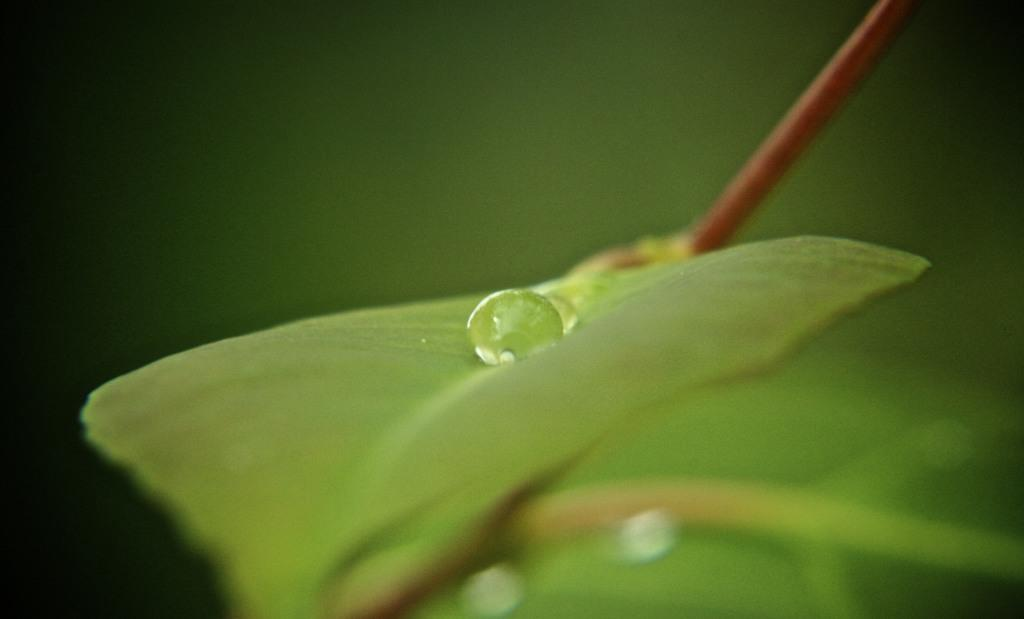What is present on the leaf in the image? There are droplets of water on a leaf in the image. Can you describe the background of the image? The background of the image is blurred. What type of club is being used to act in the image? There is no club or act present in the image; it features droplets of water on a leaf with a blurred background. 